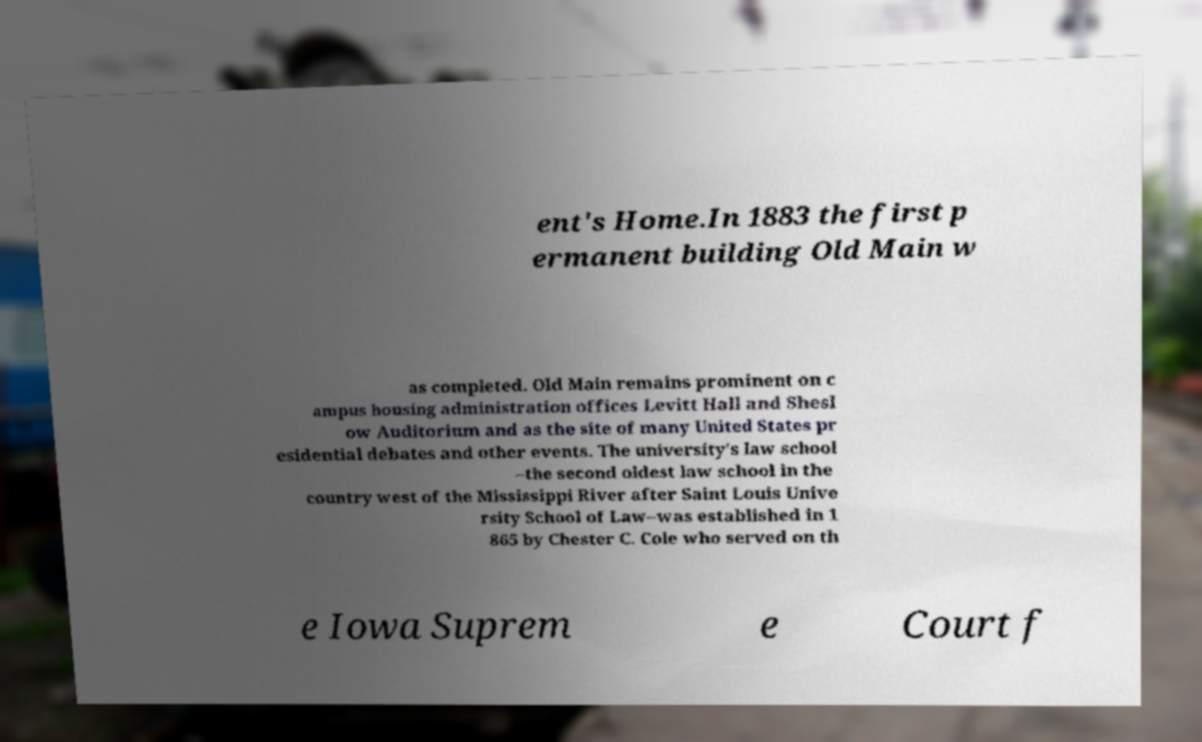I need the written content from this picture converted into text. Can you do that? ent's Home.In 1883 the first p ermanent building Old Main w as completed. Old Main remains prominent on c ampus housing administration offices Levitt Hall and Shesl ow Auditorium and as the site of many United States pr esidential debates and other events. The university's law school –the second oldest law school in the country west of the Mississippi River after Saint Louis Unive rsity School of Law–was established in 1 865 by Chester C. Cole who served on th e Iowa Suprem e Court f 